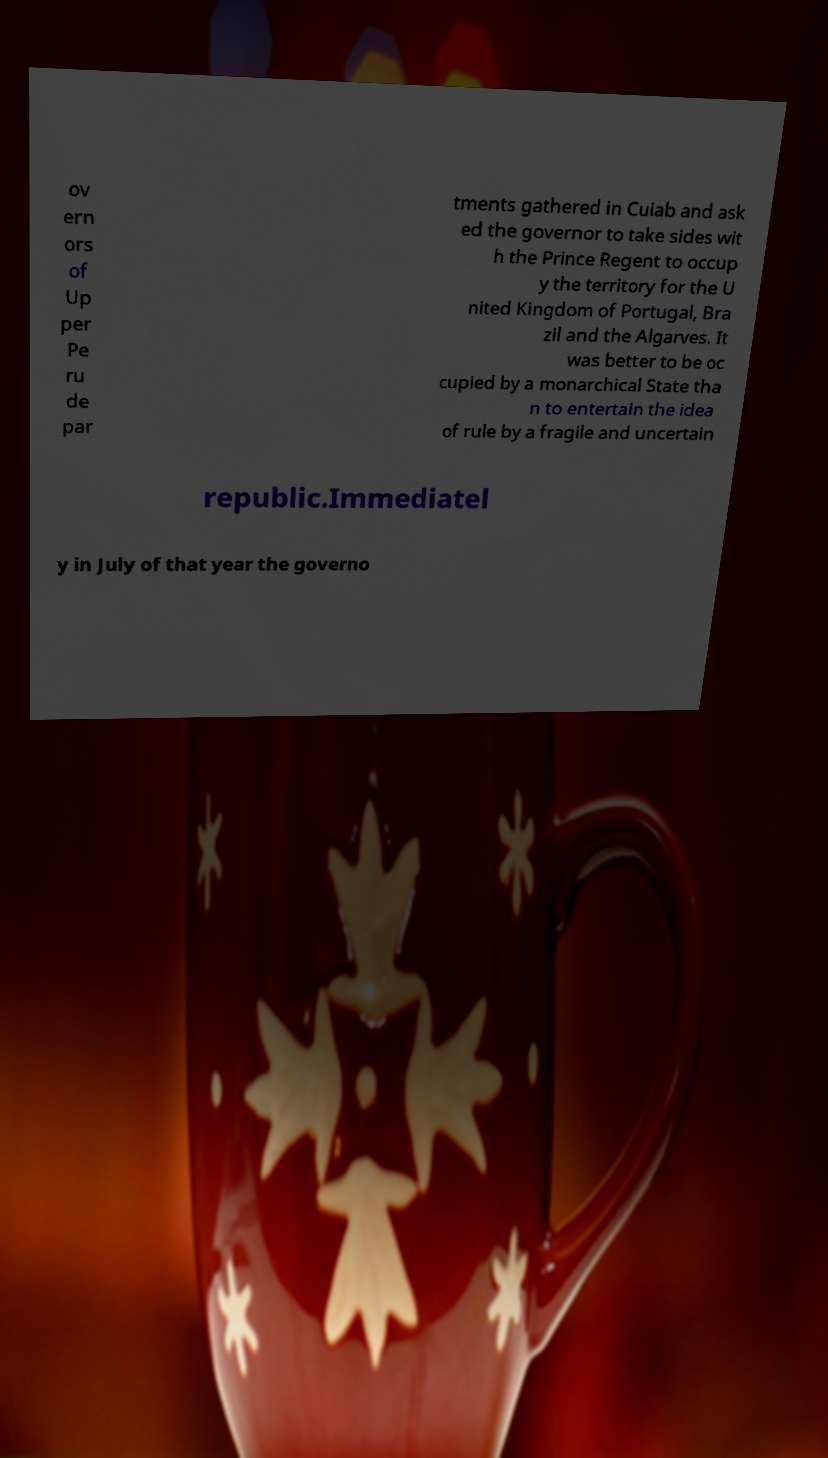There's text embedded in this image that I need extracted. Can you transcribe it verbatim? ov ern ors of Up per Pe ru de par tments gathered in Cuiab and ask ed the governor to take sides wit h the Prince Regent to occup y the territory for the U nited Kingdom of Portugal, Bra zil and the Algarves. It was better to be oc cupied by a monarchical State tha n to entertain the idea of rule by a fragile and uncertain republic.Immediatel y in July of that year the governo 